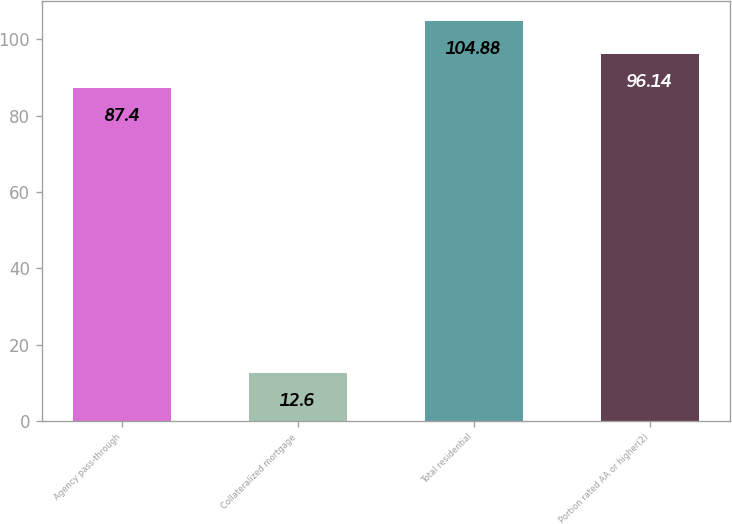<chart> <loc_0><loc_0><loc_500><loc_500><bar_chart><fcel>Agency pass-through<fcel>Collateralized mortgage<fcel>Total residential<fcel>Portion rated AA or higher(2)<nl><fcel>87.4<fcel>12.6<fcel>104.88<fcel>96.14<nl></chart> 